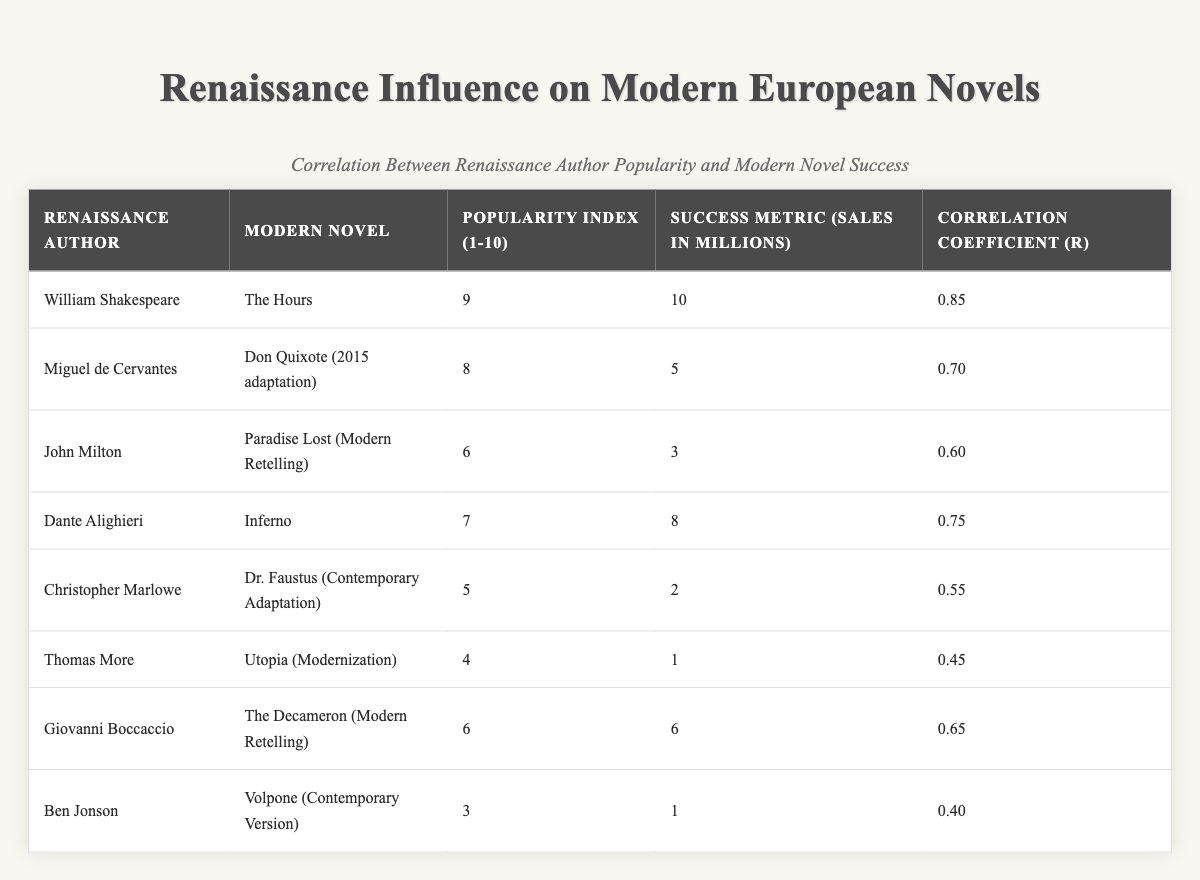What is the popularity index of William Shakespeare? The table lists William Shakespeare's popularity index in the "Popularity Index (1-10)" column, where it shows a value of 9.
Answer: 9 What is the success metric (sales in millions) of "Inferno"? By checking the "Success Metric (Sales in Millions)" column for the modern novel "Inferno," it indicates that the sales are 8 million.
Answer: 8 Which Renaissance author has the lowest correlation coefficient? The "Correlation Coefficient (r)" column shows the values, where Ben Jonson has the lowest value at 0.40.
Answer: Ben Jonson What is the average popularity index of all listed authors? The popularity indices are 9, 8, 6, 7, 5, 4, 6, and 3 which sum to 48. There are 8 authors, thus the average is 48/8 = 6.
Answer: 6 Is the correlation coefficient for "Utopia (Modernization)" higher than for "Dr. Faustus (Contemporary Adaptation)"? "Utopia (Modernization)" has a correlation coefficient of 0.45, while "Dr. Faustus (Contemporary Adaptation)" has 0.55. Since 0.45 < 0.55, the statement is false.
Answer: No Which modern novel has the highest sales, and who is its corresponding Renaissance author? The highest sales in the "Success Metric (Sales in Millions)" column is 10 million for "The Hours," which corresponds to Renaissance author William Shakespeare.
Answer: The Hours, William Shakespeare What is the difference in sales between the novels "Don Quixote (2015 adaptation)" and "The Decameron (Modern Retelling)"? "Don Quixote (2015 adaptation)" has sales of 5 million and "The Decameron (Modern Retelling)" has sales of 6 million. The difference is 6 - 5 = 1 million.
Answer: 1 million Which Renaissance author has a correlation coefficient equal to or greater than 0.75? By examining the "Correlation Coefficient (r)" column, both William Shakespeare (0.85) and Dante Alighieri (0.75) have coefficients equal to or greater than 0.75.
Answer: William Shakespeare, Dante Alighieri What percentage of the authors have a popularity index that is 5 or lower? There are 8 authors, and those with a popularity index of 5 or lower are Christopher Marlowe (5), Thomas More (4), and Ben Jonson (3). That's 3 out of 8, which is 3/8 = 0.375 or 37.5%.
Answer: 37.5% Which author appears to have the least commercial success based on the success metric? In the "Success Metric (Sales in Millions)" column, Thomas More has the lowest sales figure at 1 million, indicating the least commercial success.
Answer: Thomas More 